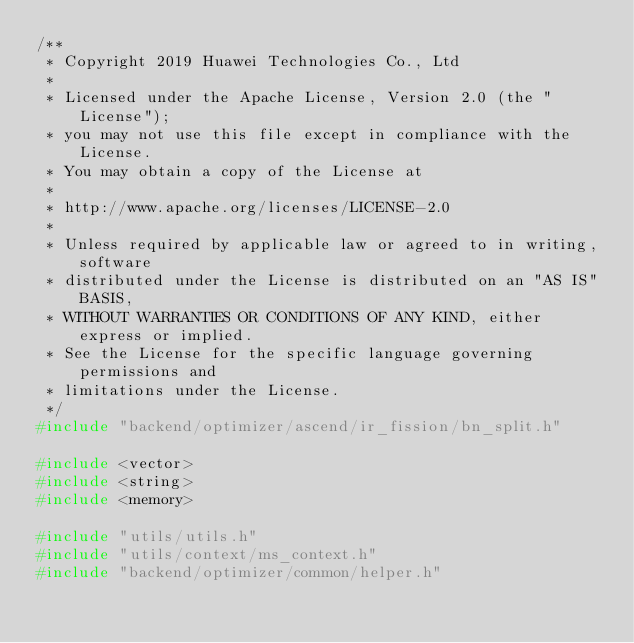<code> <loc_0><loc_0><loc_500><loc_500><_C++_>/**
 * Copyright 2019 Huawei Technologies Co., Ltd
 *
 * Licensed under the Apache License, Version 2.0 (the "License");
 * you may not use this file except in compliance with the License.
 * You may obtain a copy of the License at
 *
 * http://www.apache.org/licenses/LICENSE-2.0
 *
 * Unless required by applicable law or agreed to in writing, software
 * distributed under the License is distributed on an "AS IS" BASIS,
 * WITHOUT WARRANTIES OR CONDITIONS OF ANY KIND, either express or implied.
 * See the License for the specific language governing permissions and
 * limitations under the License.
 */
#include "backend/optimizer/ascend/ir_fission/bn_split.h"

#include <vector>
#include <string>
#include <memory>

#include "utils/utils.h"
#include "utils/context/ms_context.h"
#include "backend/optimizer/common/helper.h"</code> 